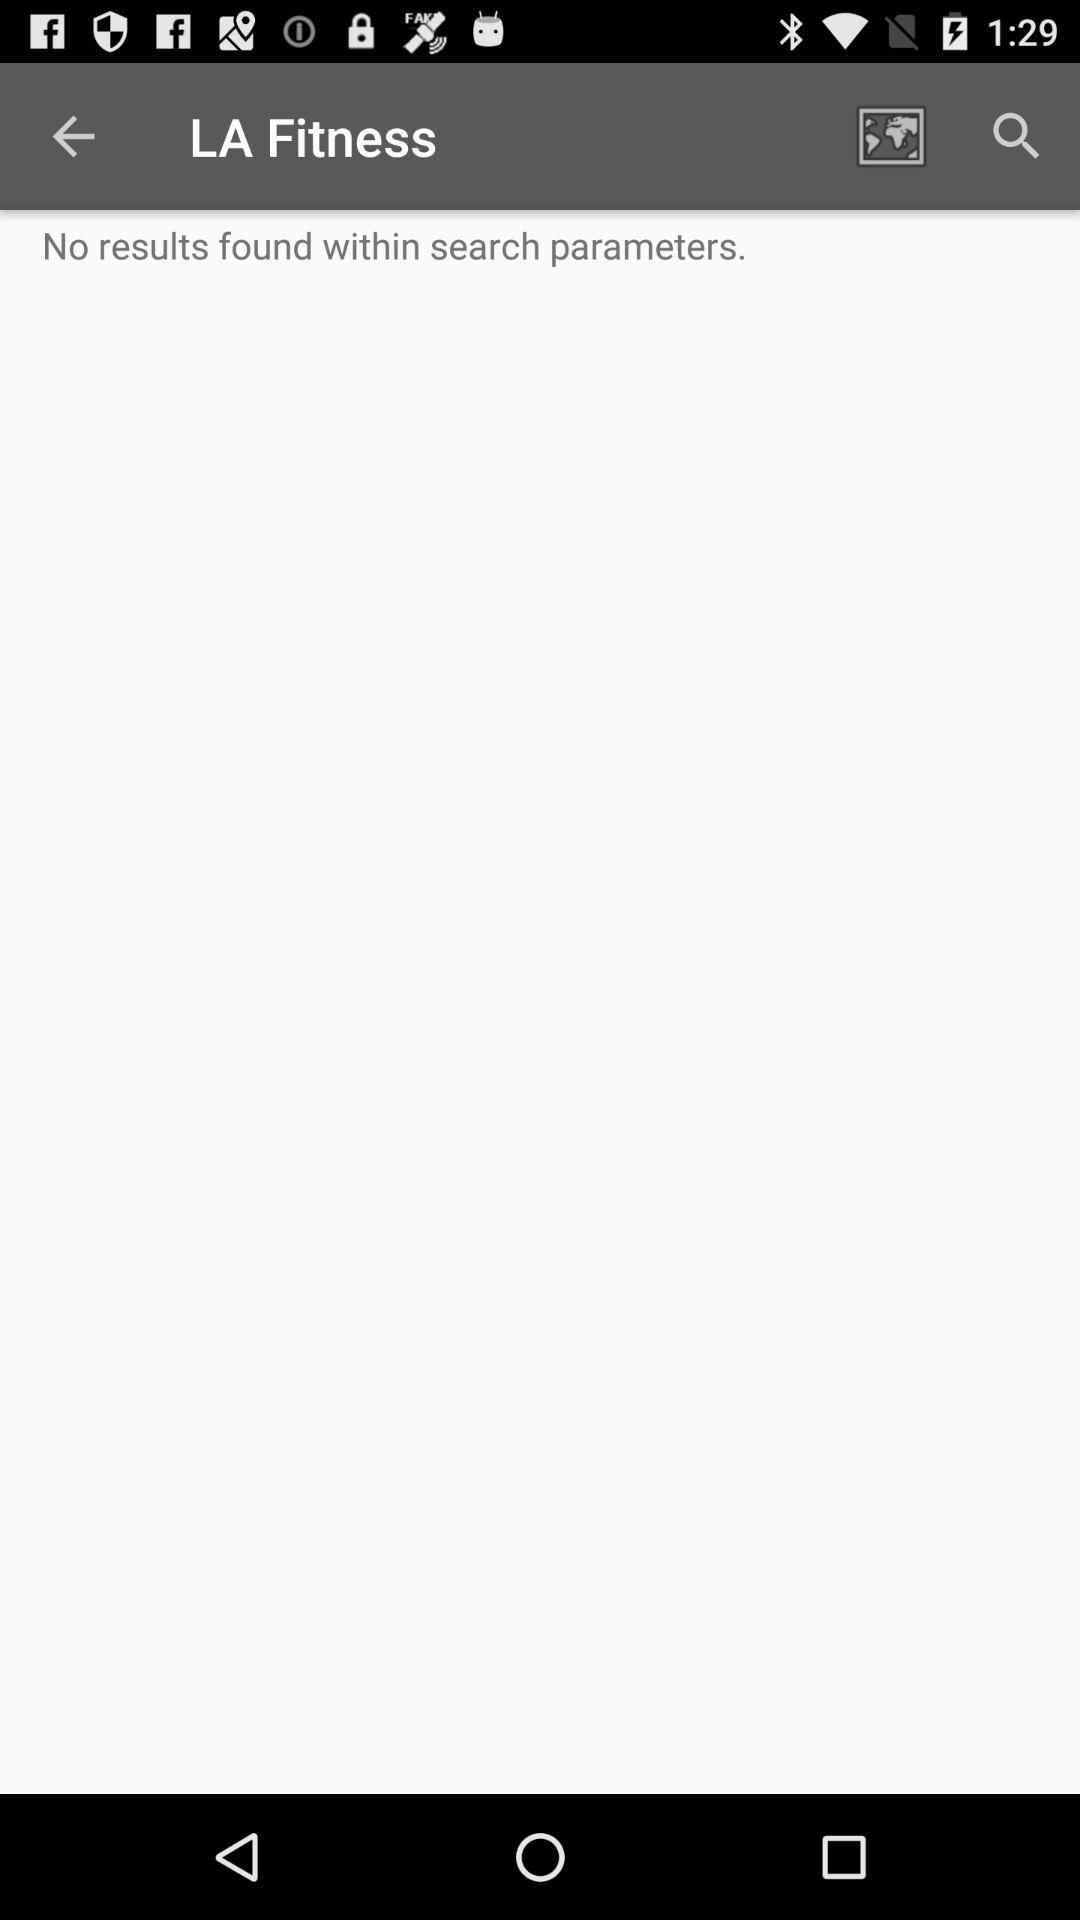When was the search performed?
When the provided information is insufficient, respond with <no answer>. <no answer> 